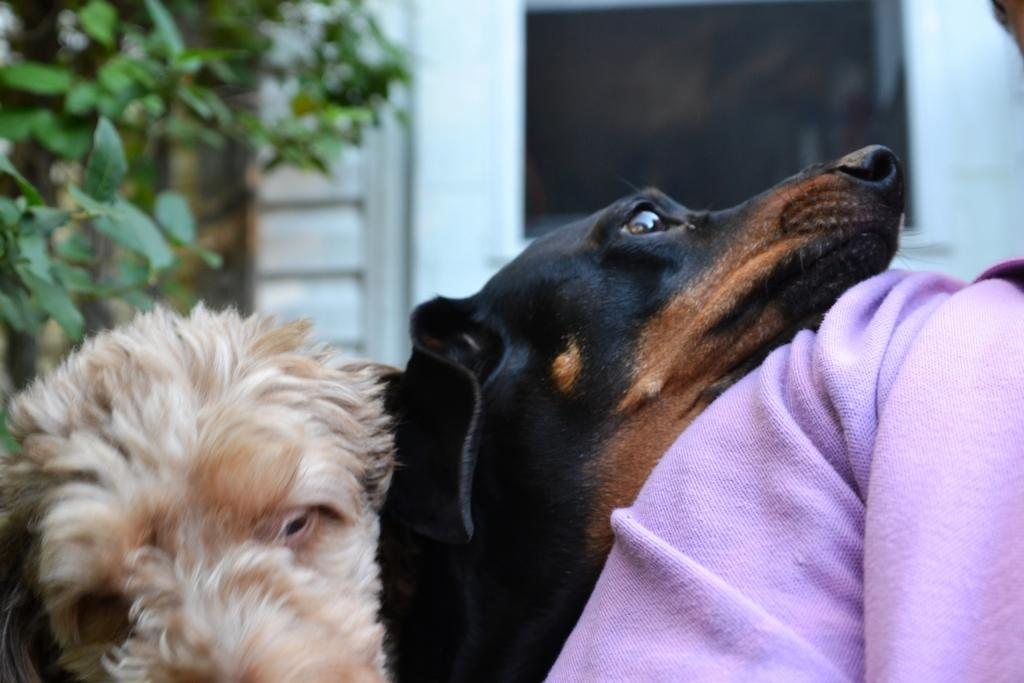What type of animals are present in the image? There are dogs in the image. Who or what is near the dogs? There is a person beside the dogs. What can be seen in the distance behind the dogs and person? There is a tree and a building in the background of the image. What type of furniture is visible in the image? There is no furniture present in the image. How many houses can be seen in the image? There is no house present in the image; only a building is visible in the background. 